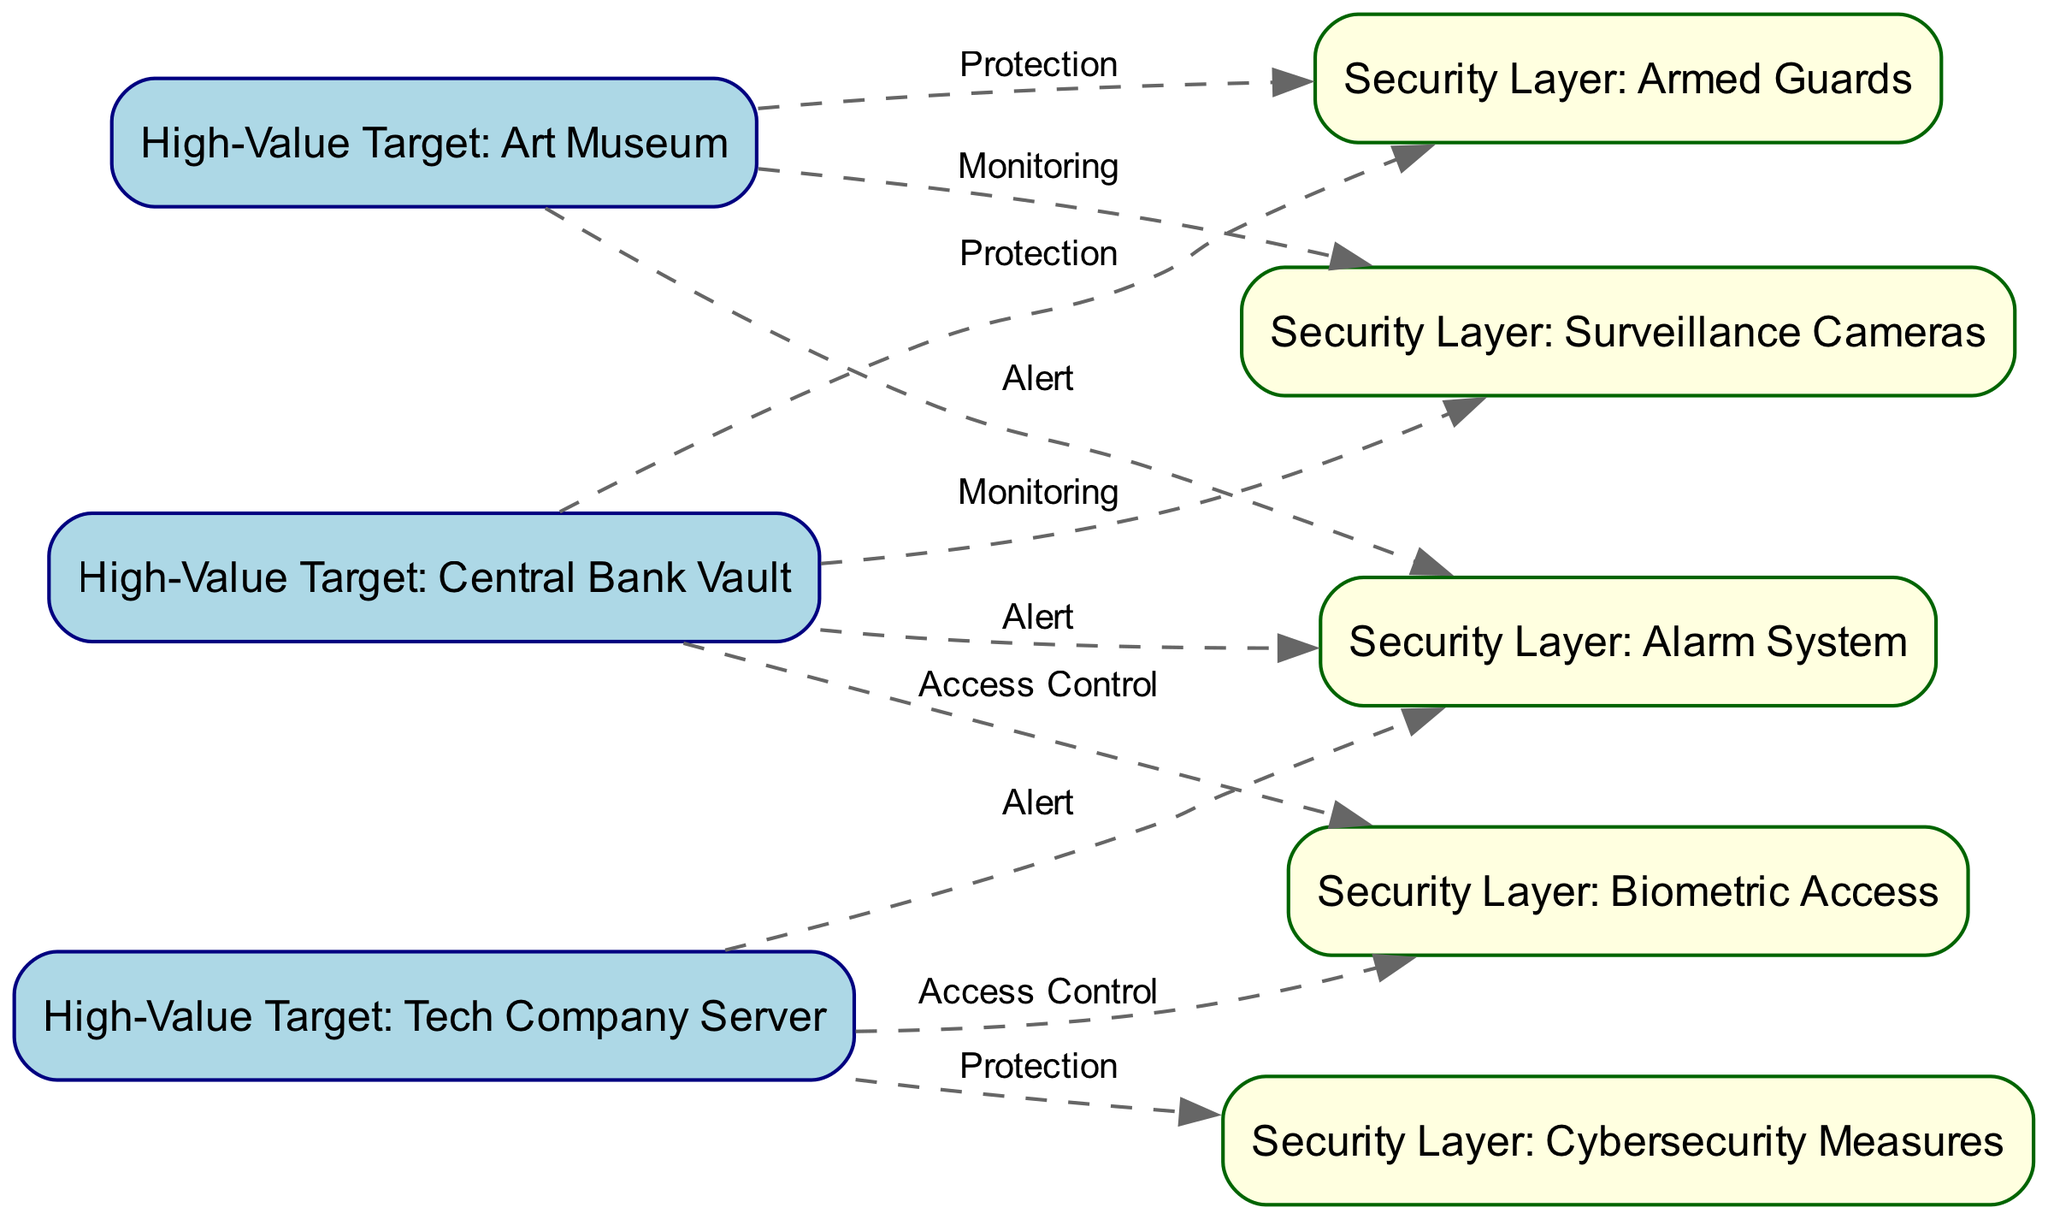What are the high-value targets represented in the diagram? The diagram includes three high-value targets: Central Bank Vault, Art Museum, and Tech Company Server. This can be identified as they are distinctly categorized with labels that begin with "High-Value Target."
Answer: Central Bank Vault, Art Museum, Tech Company Server How many security layers are depicted in the diagram? The diagram shows four security layers represented with the label "Security Layer." Counting each unique security layer listed provides the total.
Answer: 4 What type of protection does the Central Bank Vault have? The Central Bank Vault has multiple protections indicated with edges leading to it, including Armed Guards, Surveillance Cameras, Biometric Access, and Alarm System. The question specifically asks for one type of protection, which can be seen directly from the graphic connections.
Answer: Protection Which security layer is responsible for access control of the Tech Company Server? The diagram indicates that the Tech Company Server is secured by Biometric Access for access control, represented by an edge connecting node 3 to node 6. This specific relationship allows us to identify the layer.
Answer: Biometric Access How many edges connect the Art Museum to security layers? The Art Museum connects to three security layers: Armed Guards, Surveillance Cameras, and Alarm System. By checking each outgoing edge from node 2, we can enumerate these connections.
Answer: 3 Which high-value target has Cybersecurity Measures as a protective layer? The Tech Company Server is the only high-value target associated with Cybersecurity Measures, marked by the edge going from node 3 to node 8. This identification requires checking the outgoing edges from node 3.
Answer: Tech Company Server What type of alert mechanism is linked to the Central Bank Vault? The Central Bank Vault has an Alarm System as its alert mechanism, denoted by an edge connecting it to node 7, representing that specific layer of response. To validate this, we follow the edge from the relevant target to its alert system.
Answer: Alarm System Which security layer is shared between the Central Bank Vault and the Art Museum? Both the Central Bank Vault and Art Museum share the security layer of Armed Guards, as the edges from both nodes connect to this particular layer. Identifying shared elements requires analyzing the connections made to the same node.
Answer: Armed Guards What do all high-value targets in the diagram have in common regarding security? All high-value targets have multiple forms of security protection outlined in the diagram, suggesting that diverse measures are in place for the protection of valuable assets. This is determined by examining the connectivity of each high-value target to various security layers.
Answer: Multiple protections 